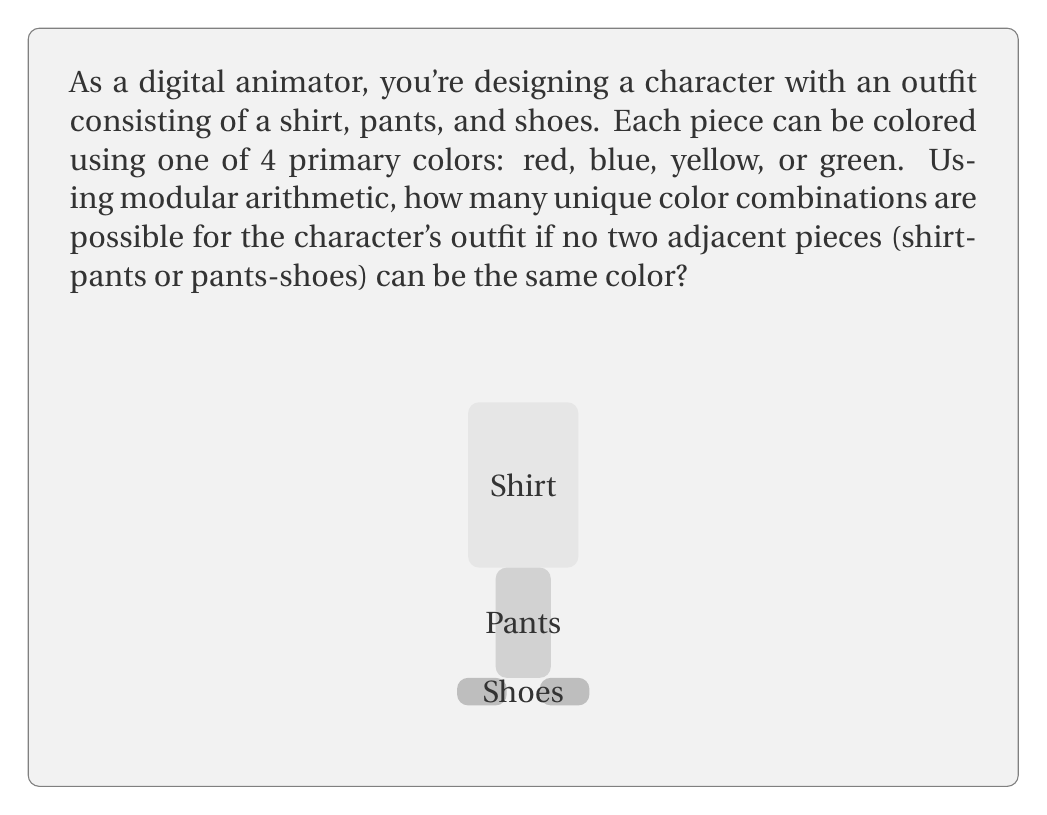Can you solve this math problem? Let's approach this step-by-step using modular arithmetic and the Multiplication Principle:

1) First, we need to consider the shirt. There are 4 color choices for the shirt, so we have 4 options here.

2) For the pants, we can't use the same color as the shirt. So we have 3 choices for the pants color. We can represent this as $(4-1) \equiv 3 \pmod{4}$.

3) For the shoes, we can't use the same color as the pants. Again, we have 3 choices. This can also be represented as $(4-1) \equiv 3 \pmod{4}$.

4) By the Multiplication Principle, the total number of possible combinations is the product of the number of choices for each piece:

   $$ 4 \cdot 3 \cdot 3 = 36 $$

5) We can express this using modular arithmetic as:

   $$ 4 \cdot (4-1) \cdot (4-1) \equiv 4 \cdot 3 \cdot 3 \equiv 36 \pmod{4} $$

Therefore, there are 36 possible unique color combinations for the character's outfit that satisfy the given conditions.
Answer: 36 